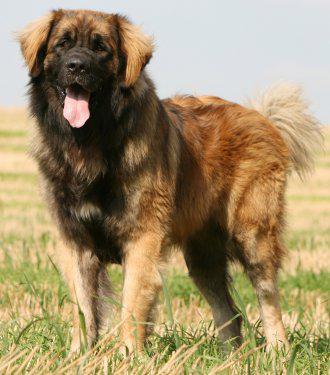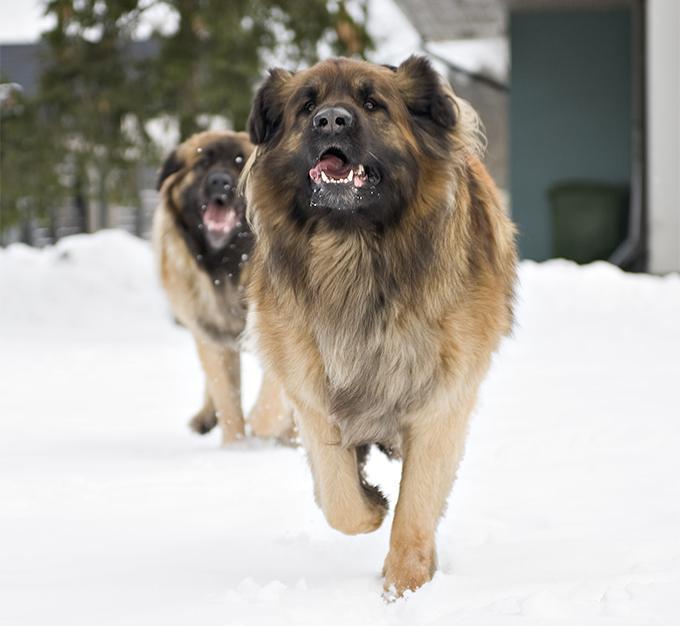The first image is the image on the left, the second image is the image on the right. Assess this claim about the two images: "At least one human is pictured with dogs.". Correct or not? Answer yes or no. No. 